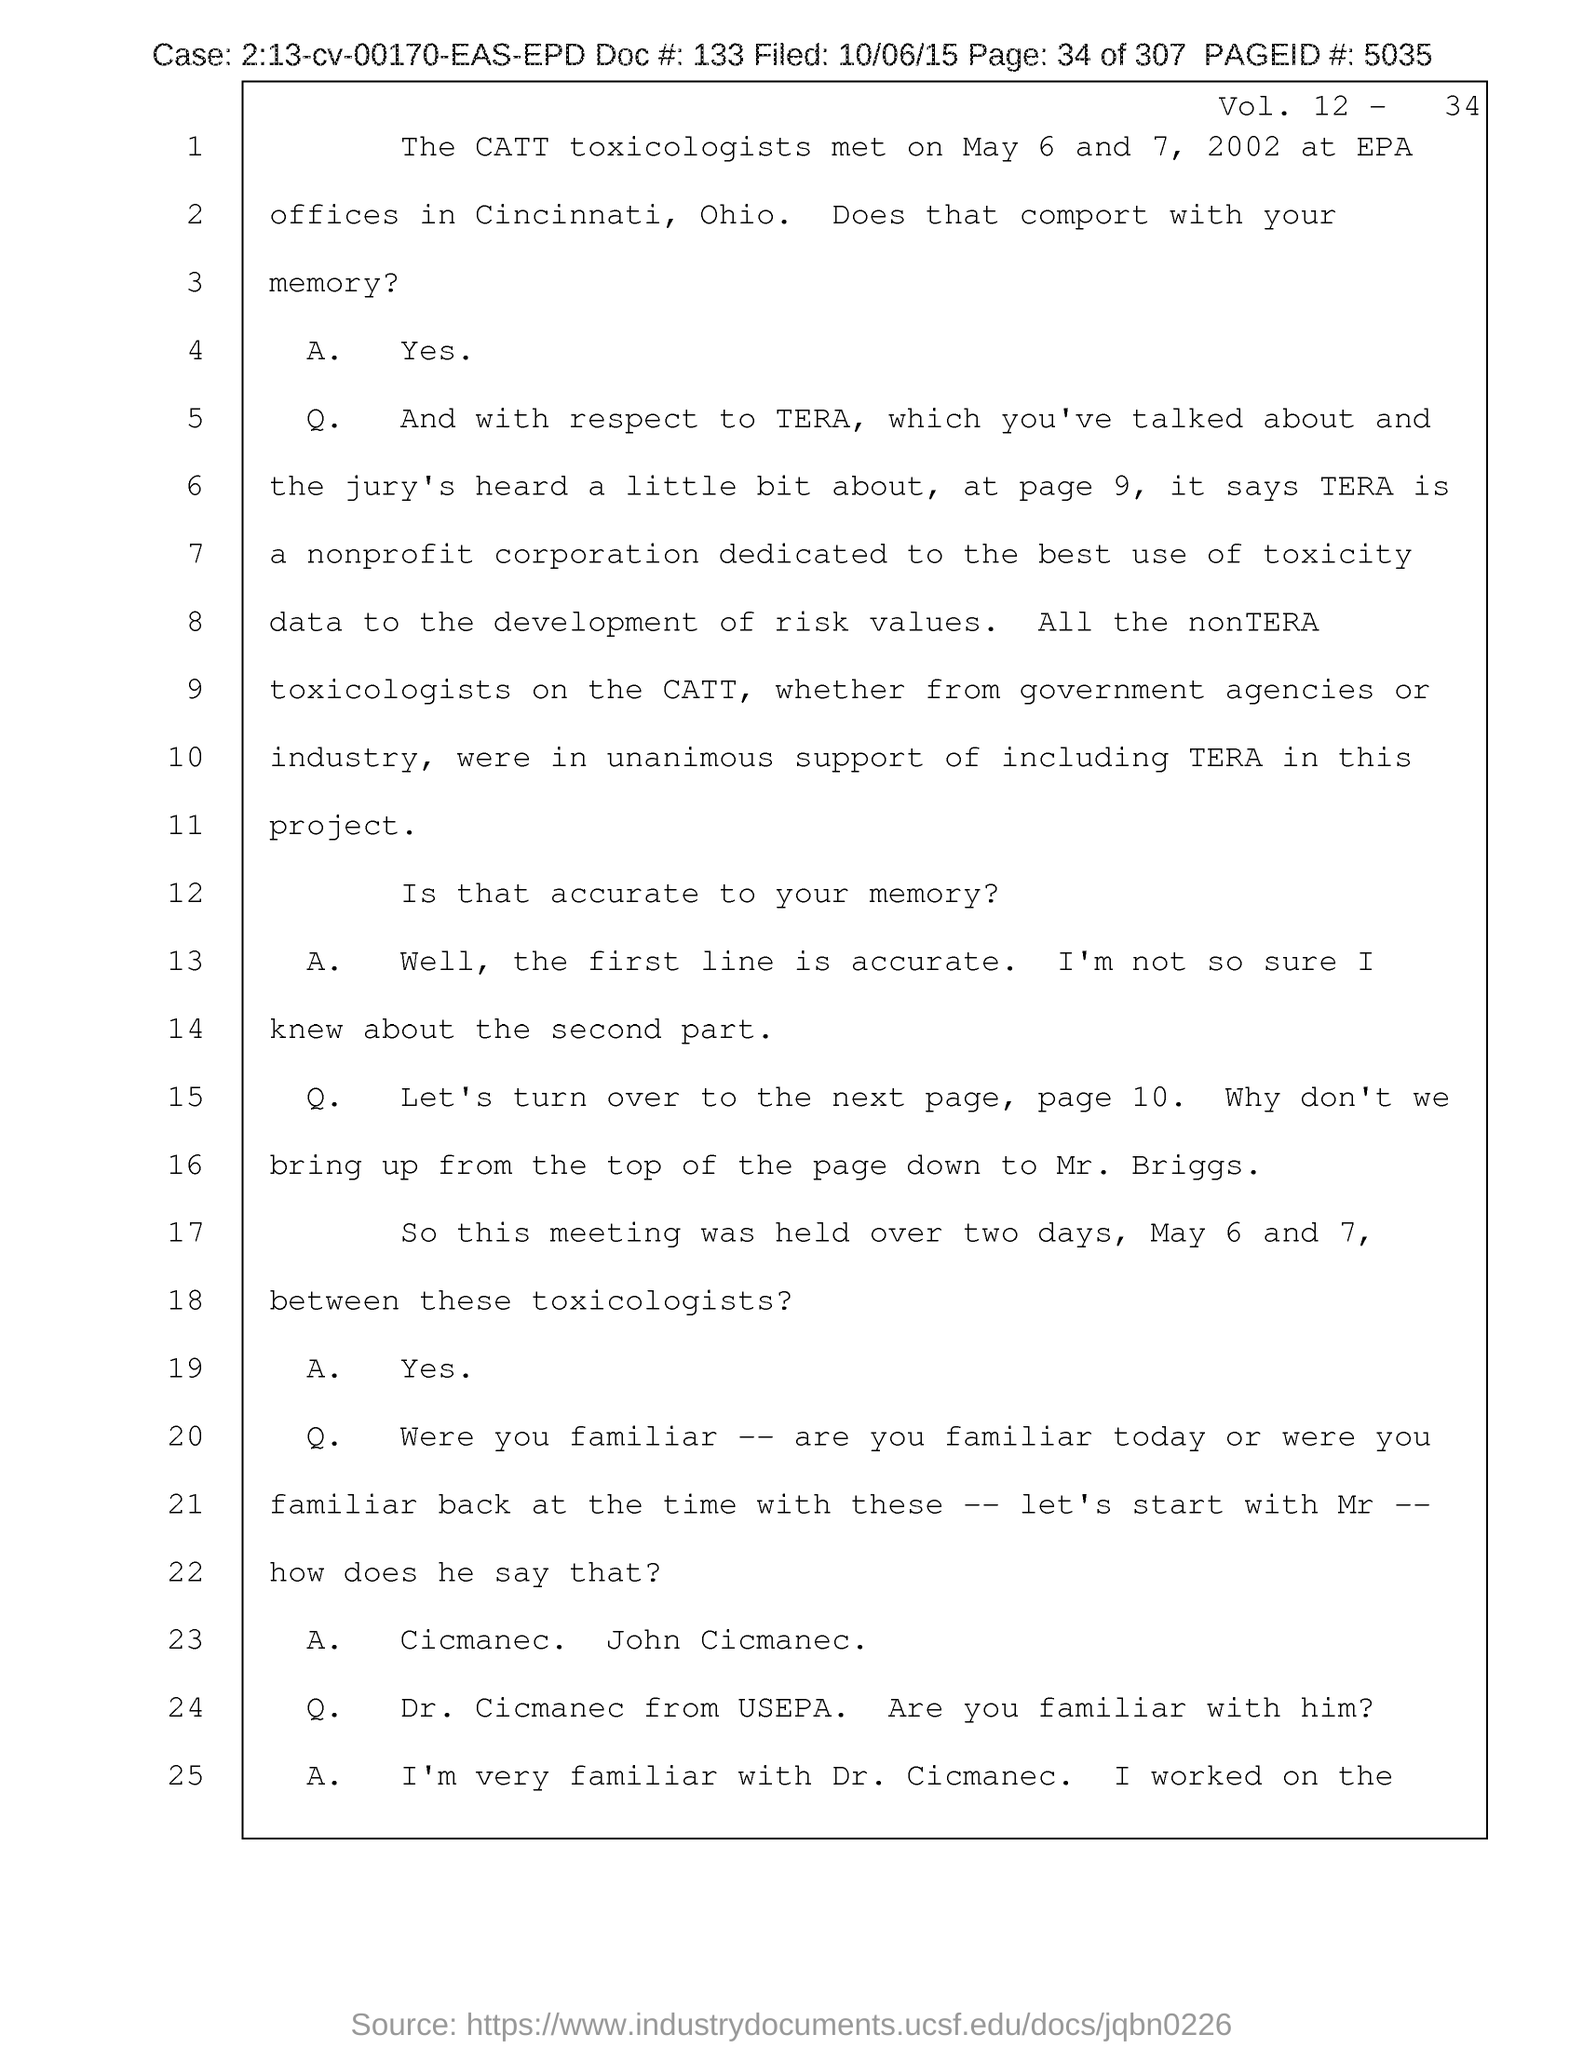Specify some key components in this picture. The volume number is 12. 